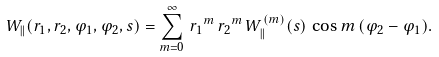<formula> <loc_0><loc_0><loc_500><loc_500>W _ { \| } ( r _ { 1 } , r _ { 2 } , \varphi _ { 1 } , \varphi _ { 2 } , s ) = \sum _ { m = 0 } ^ { \infty } \, { r _ { 1 } } ^ { m } \, { r _ { 2 } } ^ { m } \, W ^ { ( m ) } _ { \| } ( s ) \, \cos m \, ( \varphi _ { 2 } - \varphi _ { 1 } ) .</formula> 